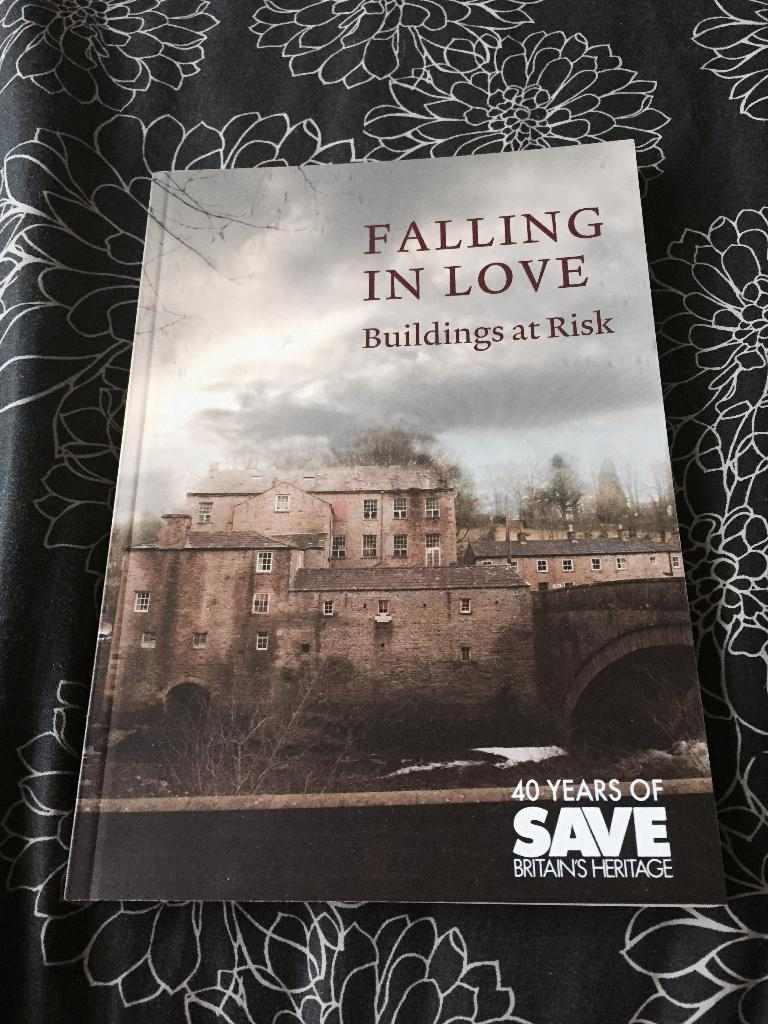Provide a one-sentence caption for the provided image. Book about Britain's Heritage titled Falling in Love, Buildings at Risk. 